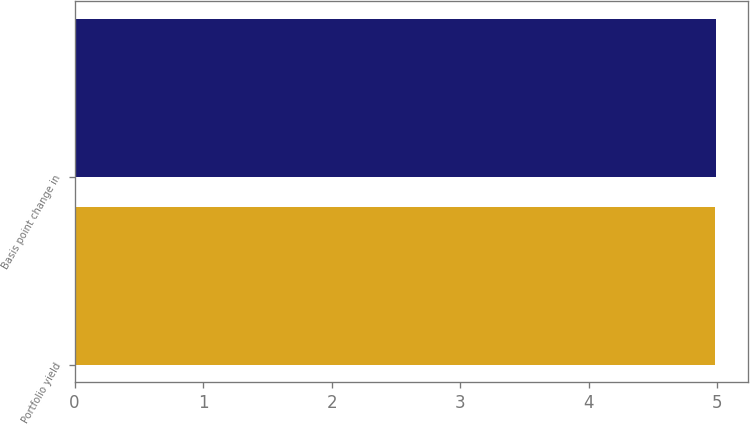Convert chart. <chart><loc_0><loc_0><loc_500><loc_500><bar_chart><fcel>Portfolio yield<fcel>Basis point change in<nl><fcel>4.98<fcel>4.99<nl></chart> 